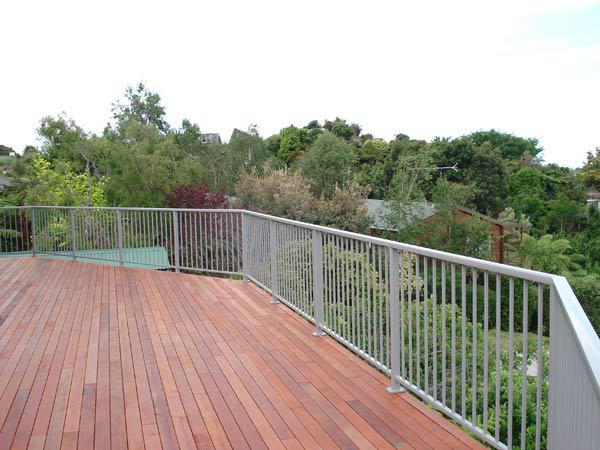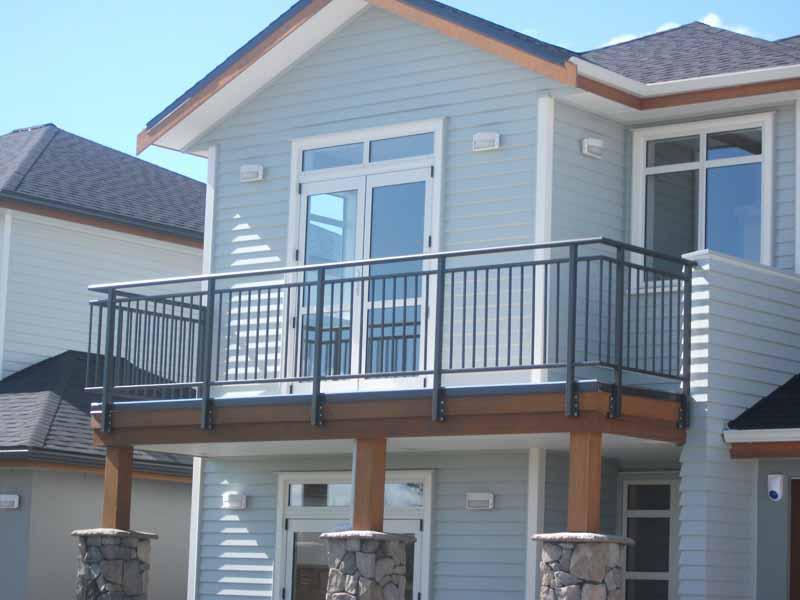The first image is the image on the left, the second image is the image on the right. Evaluate the accuracy of this statement regarding the images: "There is a glass railing.". Is it true? Answer yes or no. No. The first image is the image on the left, the second image is the image on the right. Examine the images to the left and right. Is the description "A balcony has a glass fence in one of the images." accurate? Answer yes or no. No. 